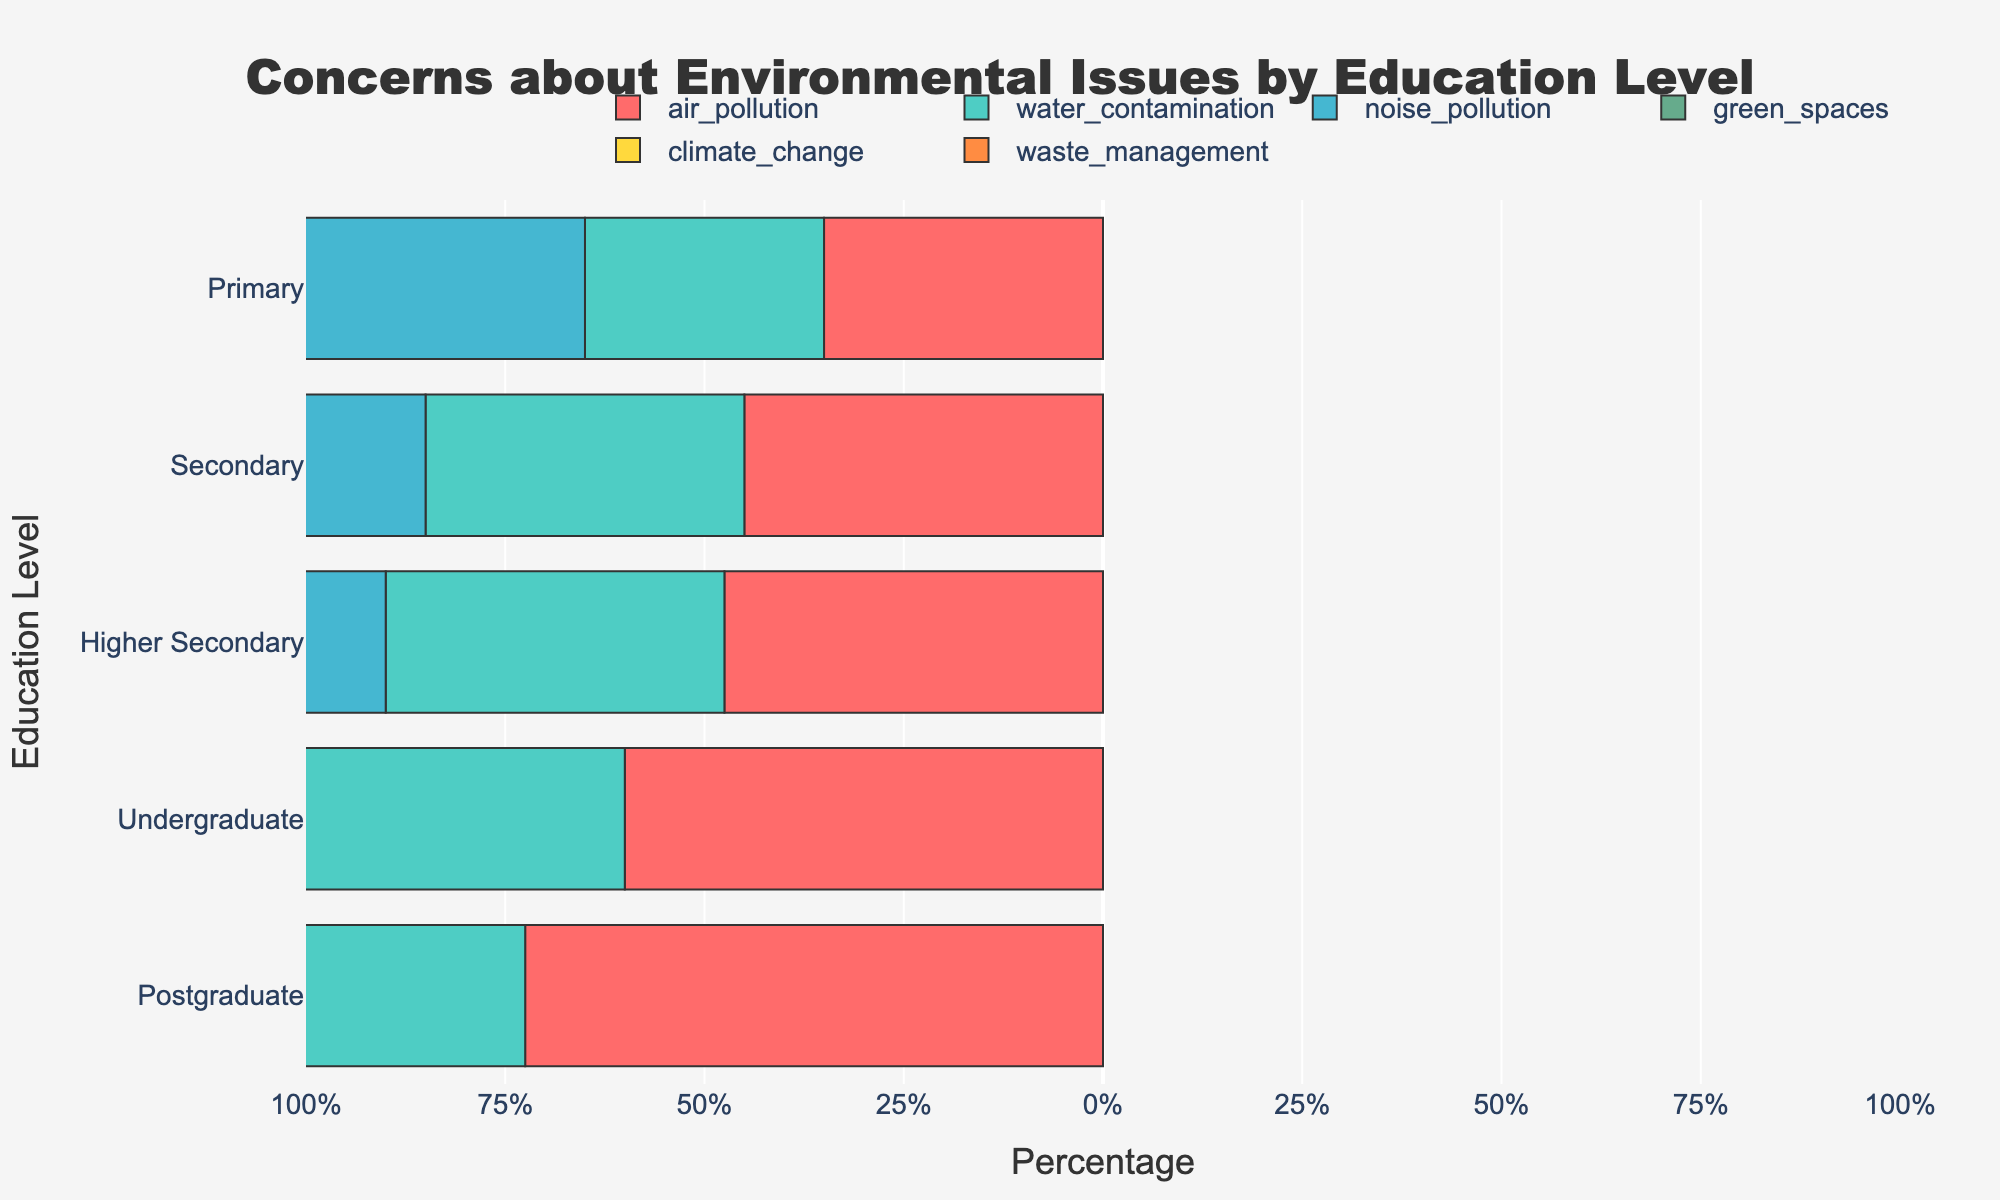Which education level has the highest concern for air pollution? Postgraduates have the highest value for air pollution among all the education levels.
Answer: Postgraduate Compare the concern for noise pollution between 'Secondary' and 'Undergraduate' education levels. Which one is higher? The concern for noise pollution in 'Secondary' education is 15, while it is 25 for 'Undergraduate'. Thus, 'Undergraduate' has a higher concern.
Answer: Undergraduate Which category has the lowest percentage of concern for 'Primary' education level? For 'Primary' education level, the lowest concern is for 'Green Spaces' with a value of 5.
Answer: Green Spaces Sum the values of 'Climate Change' concerns for all education levels. Summing 'Climate Change' concerns: 30 (Primary) + 35 (Secondary) + 30 (Higher Secondary) + 40 (Undergraduate) + 50 (Postgraduate) = 185.
Answer: 185 Compare the total concerns for environmental issues between 'Primary' and 'Postgraduate' education levels. Which one is higher? Sum for Primary: 15 + 20 + 10 + 5 + 30 + 20 = 100; Sum for Postgraduate: 5 + 10 + 30 + 25 + 50 + 35 = 155. 'Postgraduate' is higher.
Answer: Postgraduate Which education level shows a peak concern for waste management, and what is the value? Postgraduates have the highest concern for waste management among all education levels, with the value being 35.
Answer: Postgraduate, 35 Identify which education level has a balanced concern across all categories (smallest range between highest and lowest concern). The range can be calculated as the difference between the highest and lowest concern values for each level. For Primary: range = 30 - 5 = 25; Secondary: 35 - 10 = 25; Higher Secondary: 30 - 15 = 15; Undergraduate: 40 - 10 = 30; Postgraduate: 50 - 5 = 45. Thus, 'Higher Secondary' has the smallest range of concern (15).
Answer: Higher Secondary 